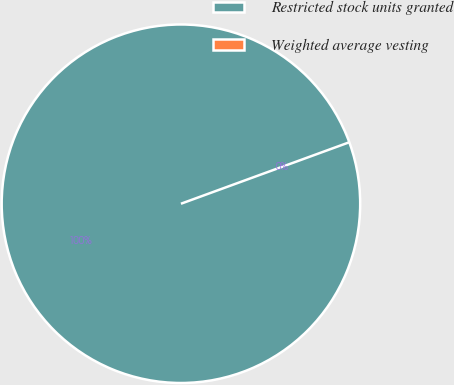<chart> <loc_0><loc_0><loc_500><loc_500><pie_chart><fcel>Restricted stock units granted<fcel>Weighted average vesting<nl><fcel>100.0%<fcel>0.0%<nl></chart> 